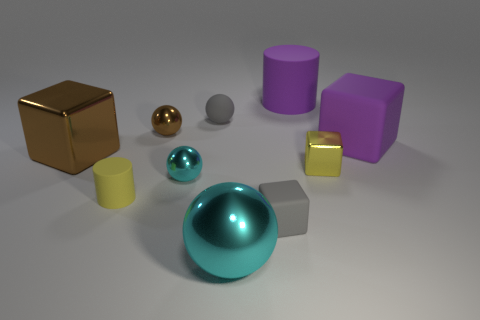There is a big rubber thing on the left side of the large purple matte cube; does it have the same color as the small matte ball behind the large shiny ball?
Offer a very short reply. No. How many other things are the same material as the purple block?
Ensure brevity in your answer.  4. Is there a large cyan object?
Your response must be concise. Yes. Is the material of the tiny thing to the left of the brown metal ball the same as the big cyan sphere?
Offer a very short reply. No. There is a brown thing that is the same shape as the large cyan thing; what is its material?
Offer a very short reply. Metal. There is a large object that is the same color as the big cylinder; what material is it?
Your response must be concise. Rubber. Are there fewer big green shiny balls than small rubber cylinders?
Your answer should be compact. Yes. Do the matte cylinder that is on the right side of the gray block and the small cylinder have the same color?
Your answer should be compact. No. What color is the small block that is made of the same material as the big cylinder?
Offer a terse response. Gray. Do the yellow cylinder and the yellow shiny thing have the same size?
Your response must be concise. Yes. 